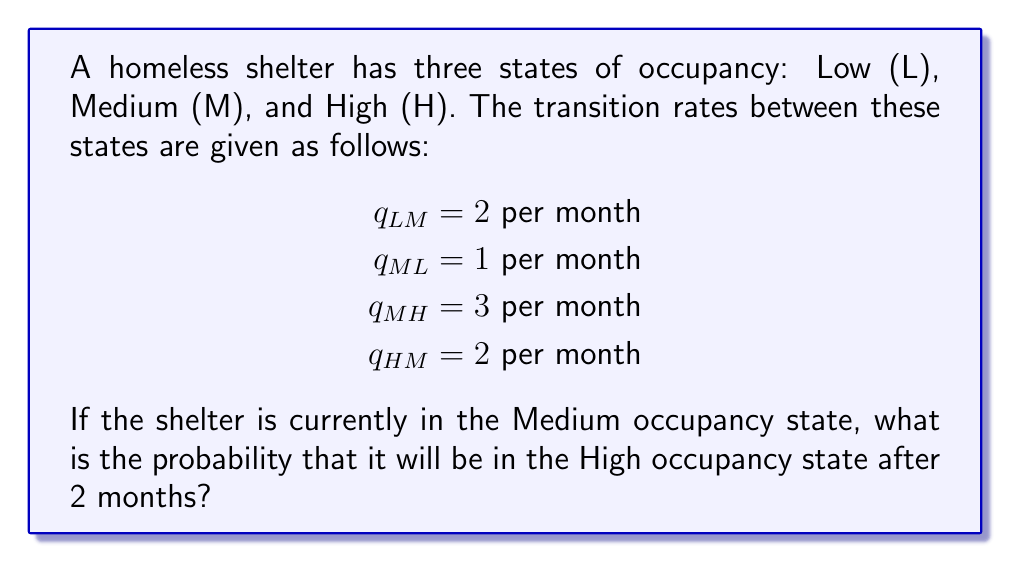Solve this math problem. To solve this problem, we need to use the continuous-time Markov chain model:

1) First, we need to set up the infinitesimal generator matrix Q:

$$Q = \begin{bmatrix}
-2 & 2 & 0 \\
1 & -4 & 3 \\
0 & 2 & -2
\end{bmatrix}$$

2) The transition probability matrix P(t) is given by:

$$P(t) = e^{Qt}$$

3) To calculate this matrix exponential, we can use the spectral decomposition method:

$$P(t) = Ve^{\Lambda t}V^{-1}$$

Where V is the matrix of eigenvectors and Λ is the diagonal matrix of eigenvalues of Q.

4) Calculating the eigenvalues and eigenvectors (this step is typically done with software):

$$\Lambda = \begin{bmatrix}
0 & 0 & 0 \\
0 & -3.7321 & 0 \\
0 & 0 & -4.2679
\end{bmatrix}$$

$$V = \begin{bmatrix}
0.4472 & -0.7746 & 0.4472 \\
0.7746 & 0.4472 & -0.4472 \\
0.4472 & 0.4472 & 0.7746
\end{bmatrix}$$

5) Now we can calculate P(2):

$$P(2) = Ve^{\Lambda 2}V^{-1}$$

6) Performing this calculation (again, typically done with software) gives:

$$P(2) = \begin{bmatrix}
0.3181 & 0.4546 & 0.2273 \\
0.2273 & 0.3181 & 0.4546 \\
0.2273 & 0.4546 & 0.3181
\end{bmatrix}$$

7) The probability of transitioning from Medium to High occupancy after 2 months is given by the element in the second row, third column of P(2), which is 0.4546.
Answer: 0.4546 